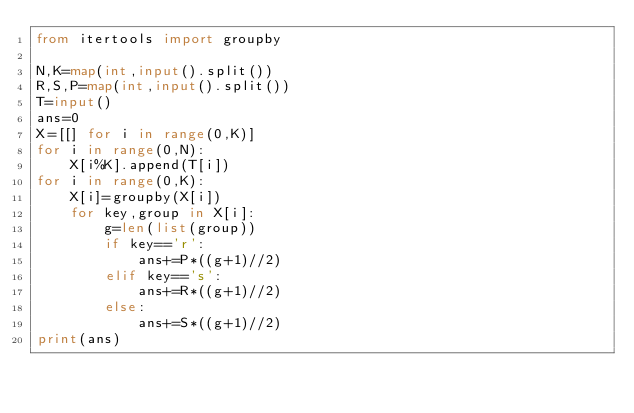<code> <loc_0><loc_0><loc_500><loc_500><_Python_>from itertools import groupby

N,K=map(int,input().split())
R,S,P=map(int,input().split())
T=input()
ans=0
X=[[] for i in range(0,K)]
for i in range(0,N):
    X[i%K].append(T[i])
for i in range(0,K):
    X[i]=groupby(X[i])
    for key,group in X[i]:
        g=len(list(group))
        if key=='r':
            ans+=P*((g+1)//2)
        elif key=='s':
            ans+=R*((g+1)//2)
        else:
            ans+=S*((g+1)//2)
print(ans)
</code> 